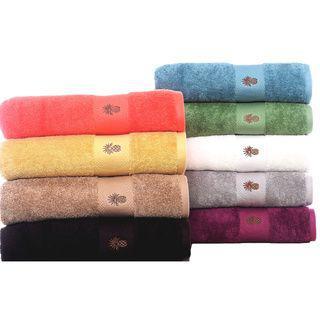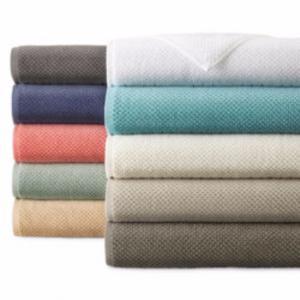The first image is the image on the left, the second image is the image on the right. Assess this claim about the two images: "There is a stack of at least five different colored towels.". Correct or not? Answer yes or no. Yes. The first image is the image on the left, the second image is the image on the right. Given the left and right images, does the statement "more than 3 stacks of colorful towels" hold true? Answer yes or no. Yes. 